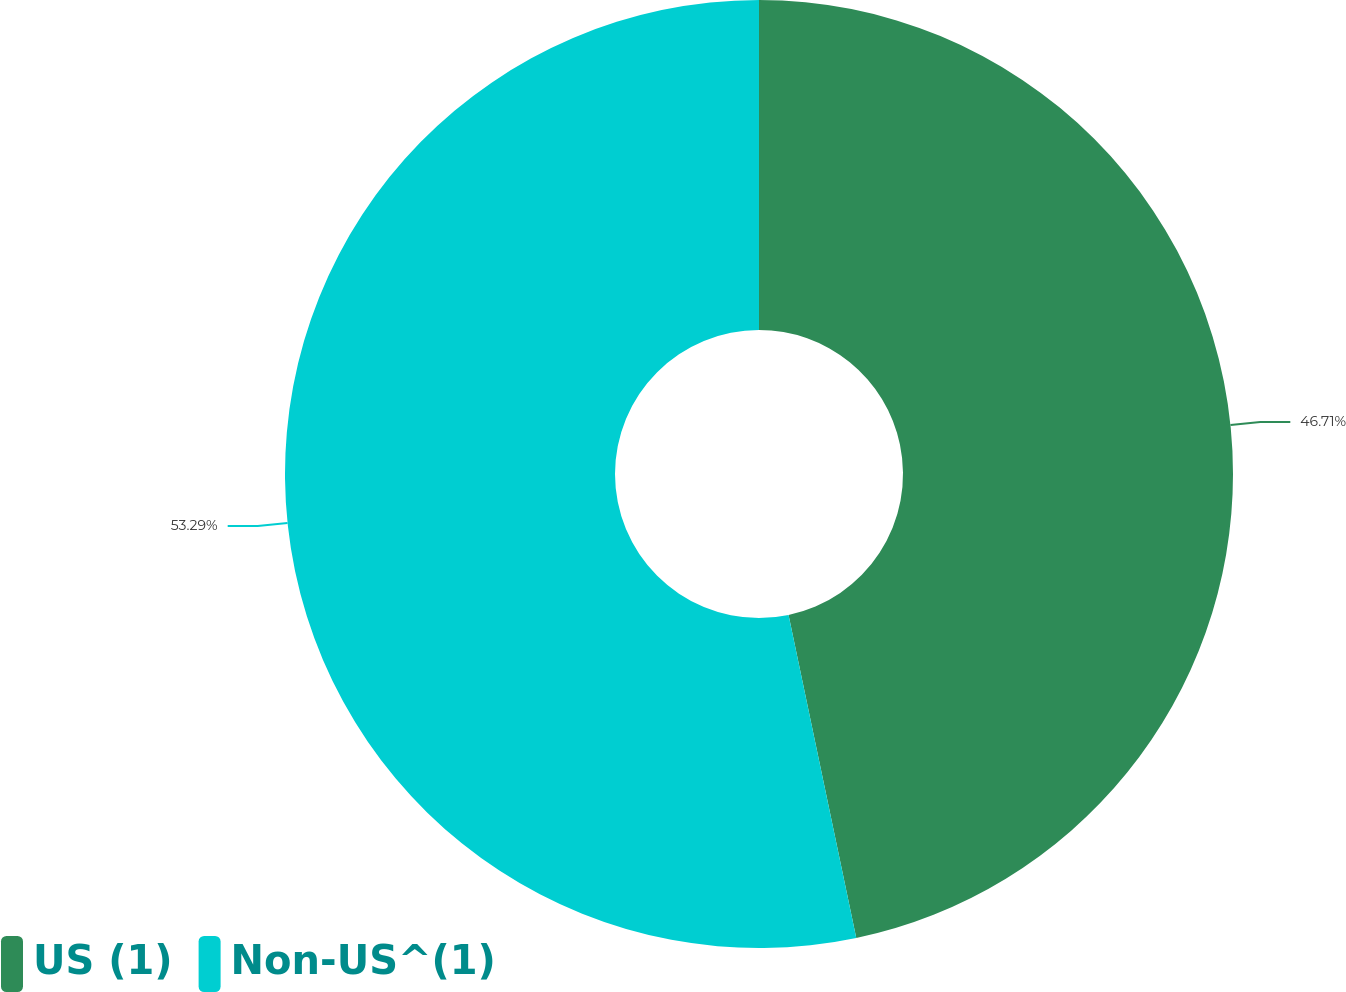Convert chart. <chart><loc_0><loc_0><loc_500><loc_500><pie_chart><fcel>US (1)<fcel>Non-US^(1)<nl><fcel>46.71%<fcel>53.29%<nl></chart> 